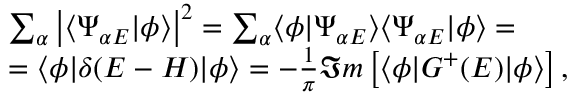Convert formula to latex. <formula><loc_0><loc_0><loc_500><loc_500>\begin{array} { r l } & { \sum _ { \alpha } \left | \langle \Psi _ { \alpha E } | \phi \rangle \right | ^ { 2 } = \sum _ { \alpha } \langle \phi | \Psi _ { \alpha E } \rangle \langle \Psi _ { \alpha E } | \phi \rangle = } \\ & { = \langle \phi | \delta ( E - H ) | \phi \rangle = - \frac { 1 } { \pi } \Im m \left [ \langle \phi | G ^ { + } ( E ) | \phi \rangle \right ] , } \end{array}</formula> 